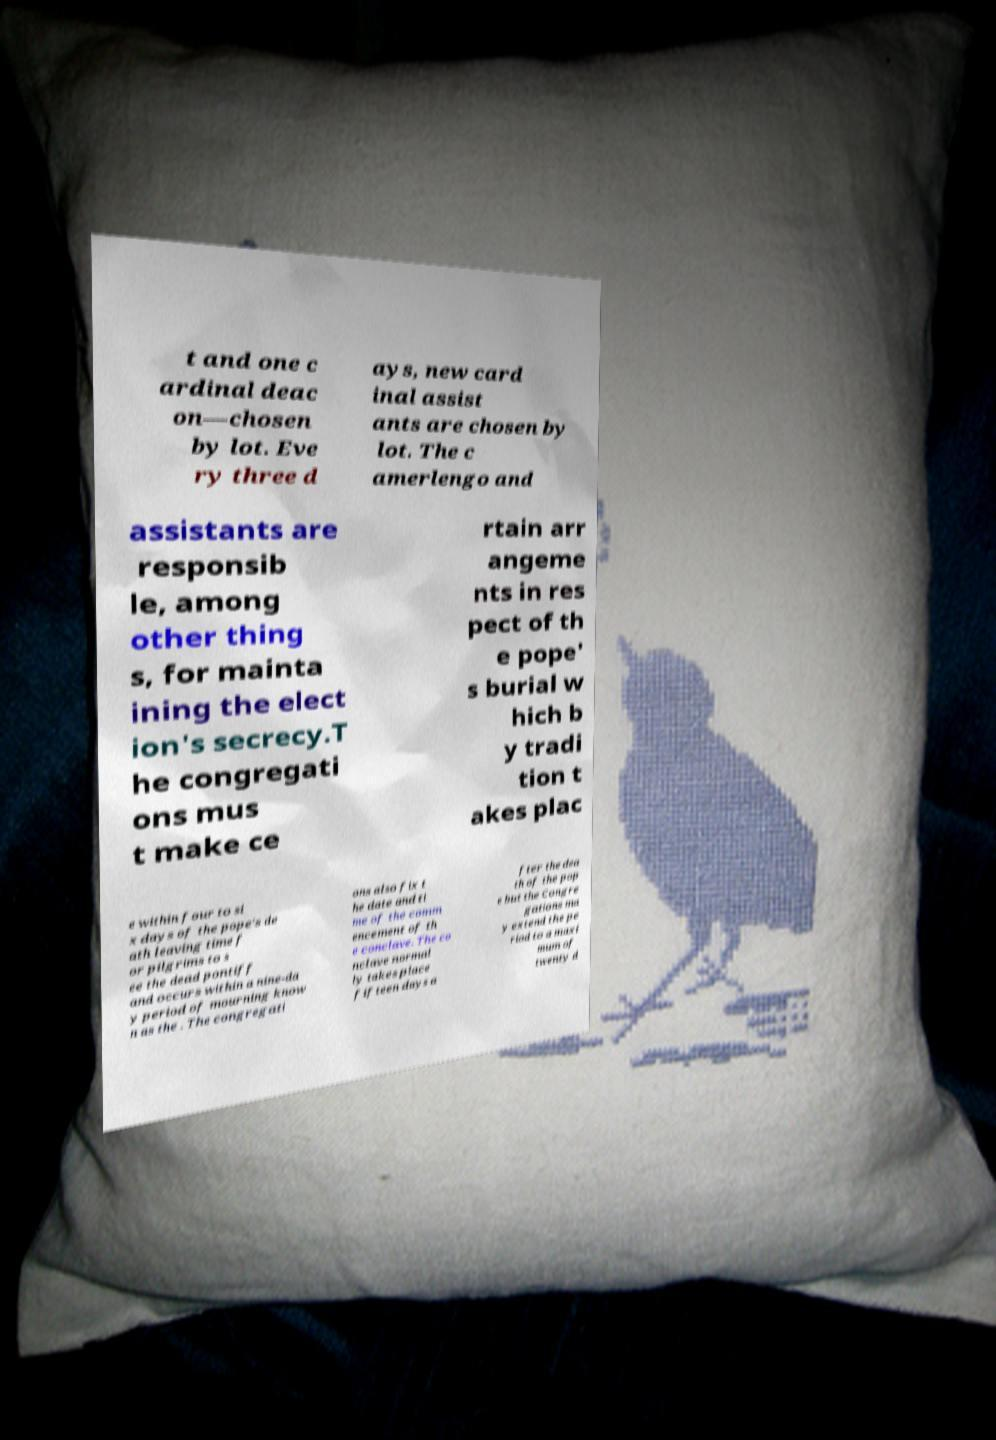Can you read and provide the text displayed in the image?This photo seems to have some interesting text. Can you extract and type it out for me? t and one c ardinal deac on—chosen by lot. Eve ry three d ays, new card inal assist ants are chosen by lot. The c amerlengo and assistants are responsib le, among other thing s, for mainta ining the elect ion's secrecy.T he congregati ons mus t make ce rtain arr angeme nts in res pect of th e pope' s burial w hich b y tradi tion t akes plac e within four to si x days of the pope's de ath leaving time f or pilgrims to s ee the dead pontiff and occurs within a nine-da y period of mourning know n as the . The congregati ons also fix t he date and ti me of the comm encement of th e conclave. The co nclave normal ly takes place fifteen days a fter the dea th of the pop e but the Congre gations ma y extend the pe riod to a maxi mum of twenty d 